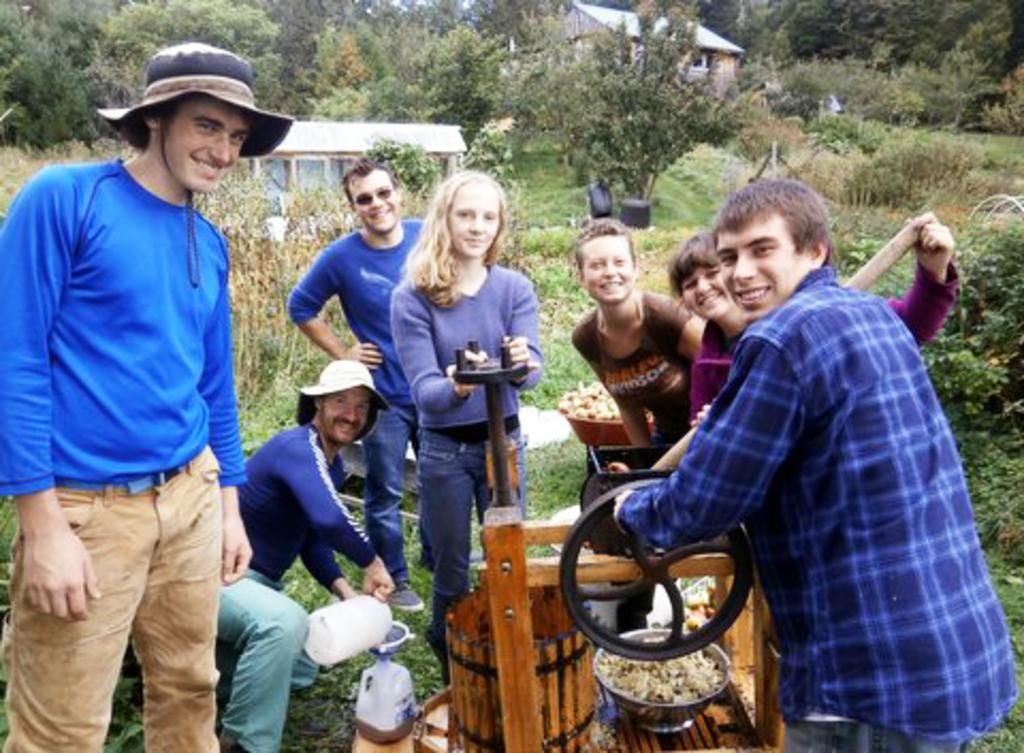What is happening in the foreground of the image? There are persons standing near a machine in the foreground of the image. How do the persons appear to be feeling? The persons have smiles on their faces. What can be seen in the background of the image? There are houses, trees, plants, and grass in the background of the image. Can you see any ghosts interacting with the persons near the machine in the image? There are no ghosts present in the image. What type of wound is visible on the person standing near the machine? There is no wound visible on any person in the image. 